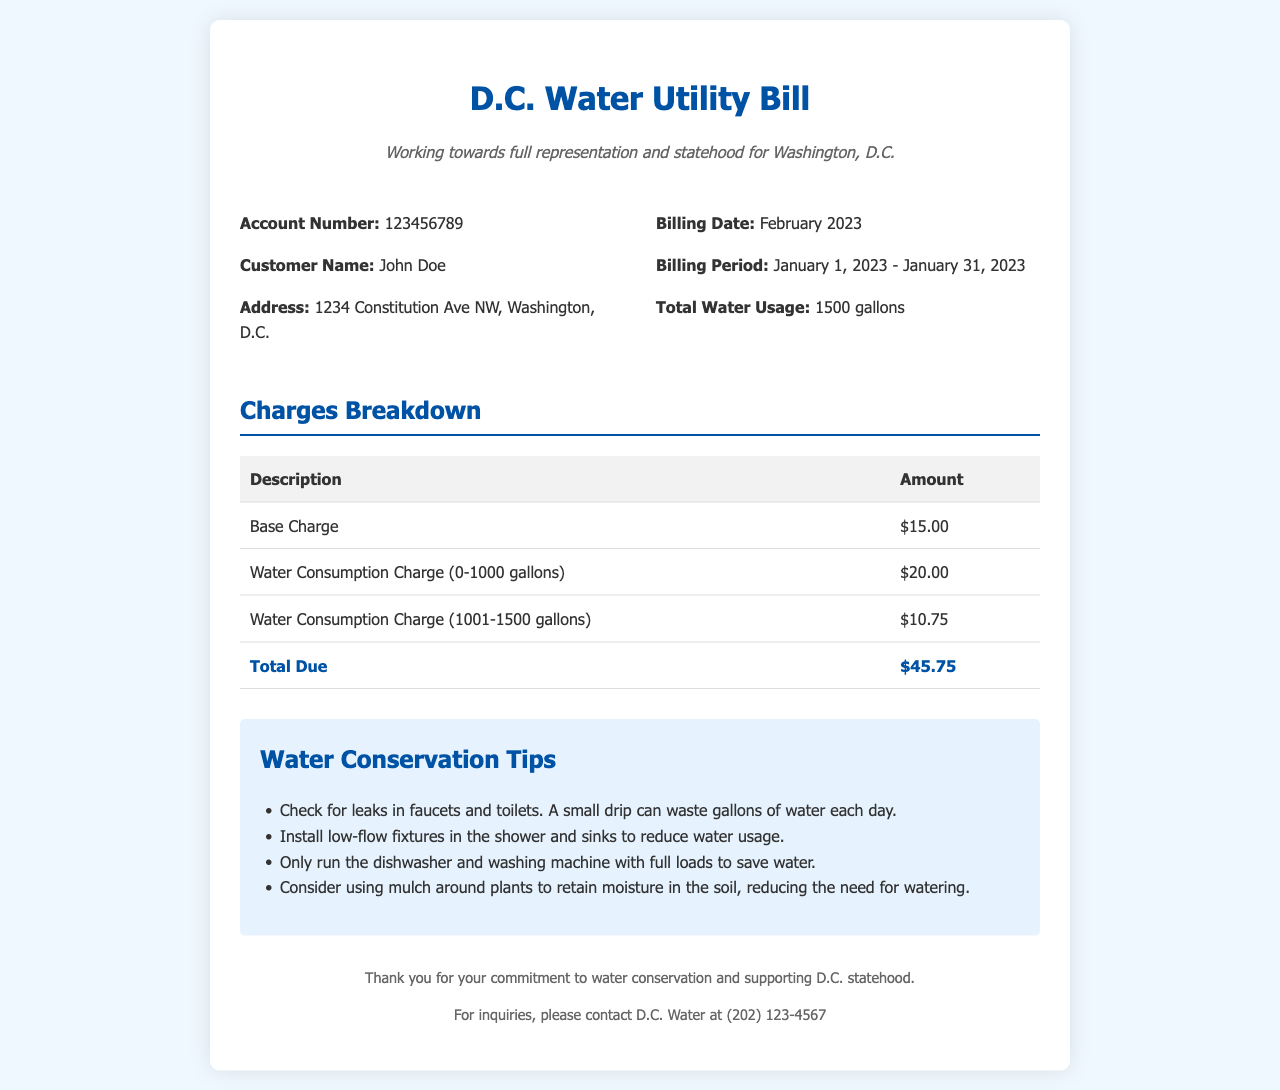What is the account number? The account number is provided in the billing information section of the document as a unique identifier for the water service.
Answer: 123456789 What was the total water usage for February 2023? The total water usage is listed under the billing information as the amount of water consumed during the billing period.
Answer: 1500 gallons What is the base charge on this utility bill? The base charge is detailed in the charges breakdown section, outlining fixed charges for service.
Answer: $15.00 What is the total amount due? The total amount due is calculated from the detailed charges at the end of the charges breakdown section.
Answer: $45.75 What is one of the water conservation tips provided? The document includes tips listing ways residents can reduce water usage and be more efficient.
Answer: Check for leaks in faucets and toilets How long was the billing period? The billing period indicates the timeframe for which the charges were applied and is specified in the bill information.
Answer: January 1, 2023 - January 31, 2023 What is the customer's name? The customer's name is specified at the beginning of the bill for identification of the water service account holder.
Answer: John Doe How many gallons are charged at the rate of $20.00? The charges breakdown specifies rates applicable to different tiers of water consumption as part of the billing process.
Answer: 1000 gallons 